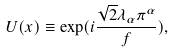<formula> <loc_0><loc_0><loc_500><loc_500>U ( x ) \equiv \exp ( i \frac { \sqrt { 2 } \lambda _ { \alpha } \pi ^ { \alpha } } { f } ) ,</formula> 